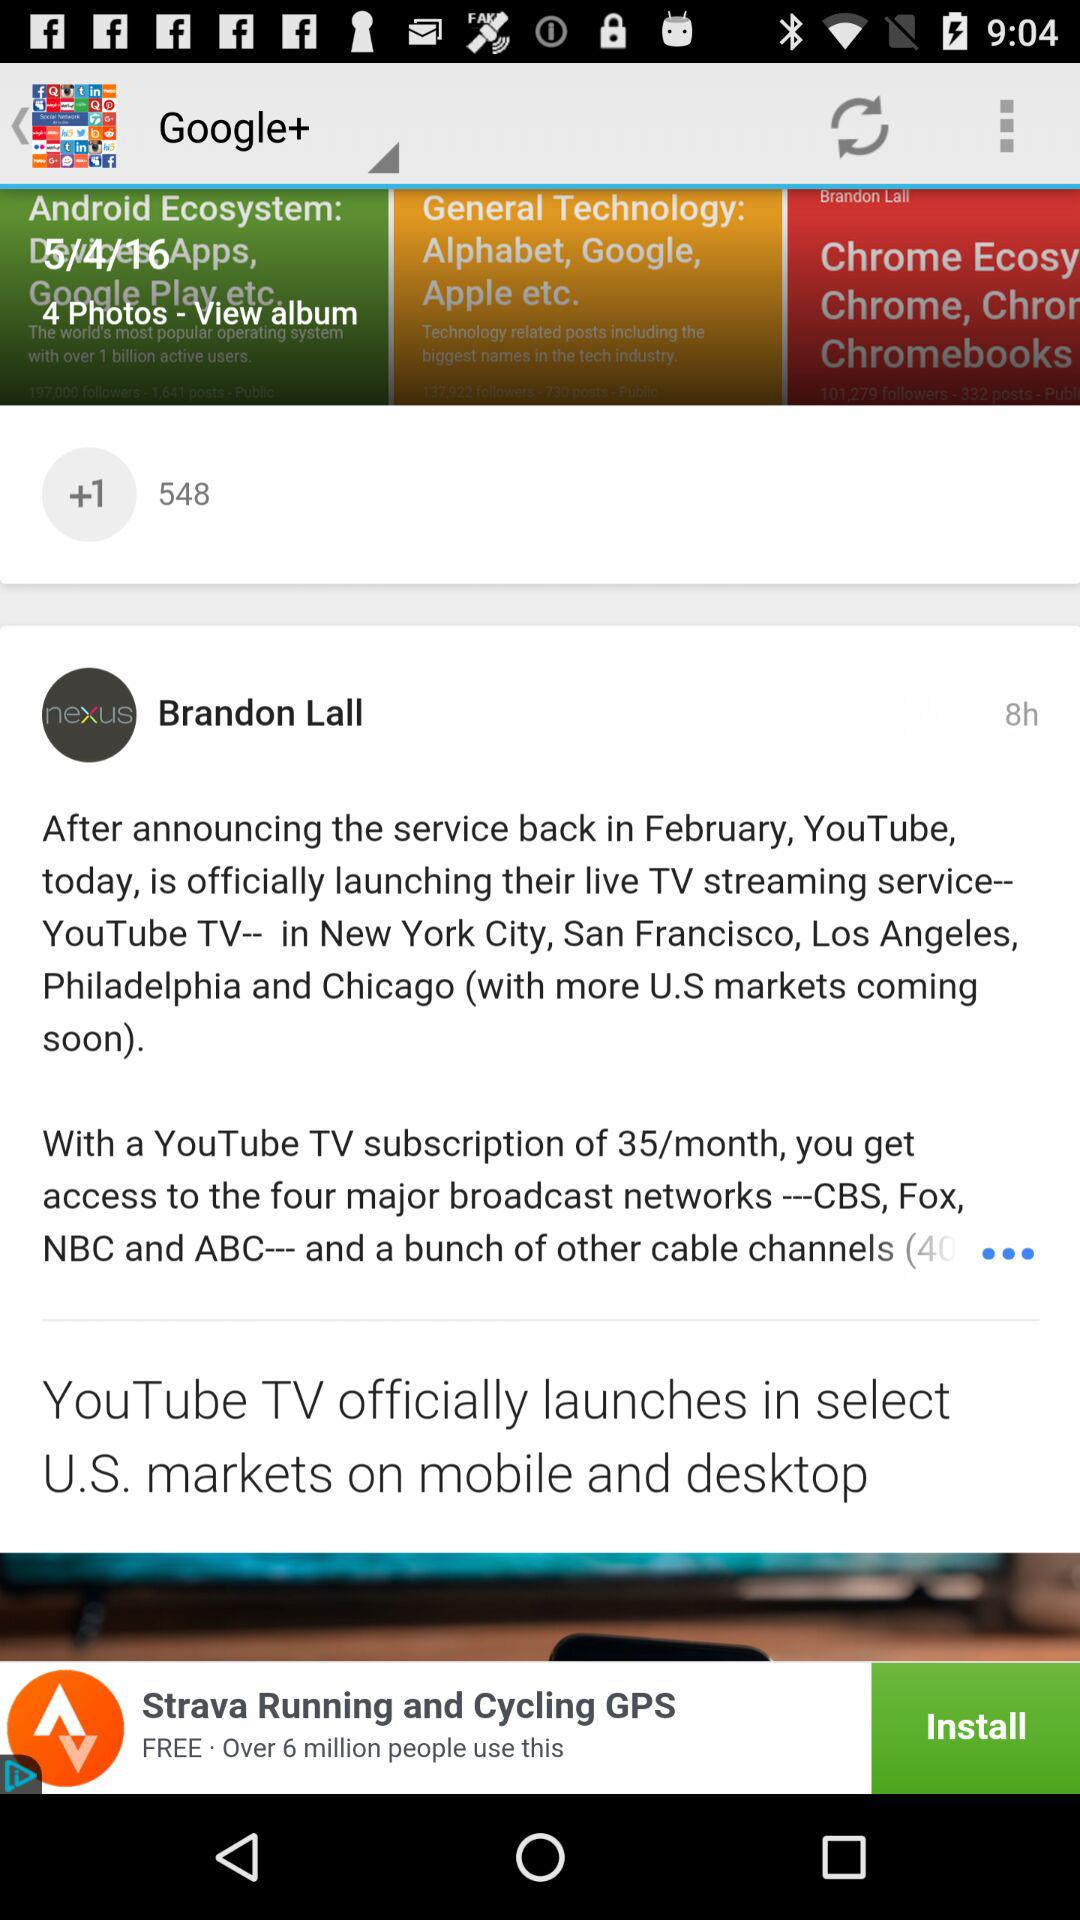What is the application name? The application names are "Google+" and "Strava Running and Cycling GPS". 